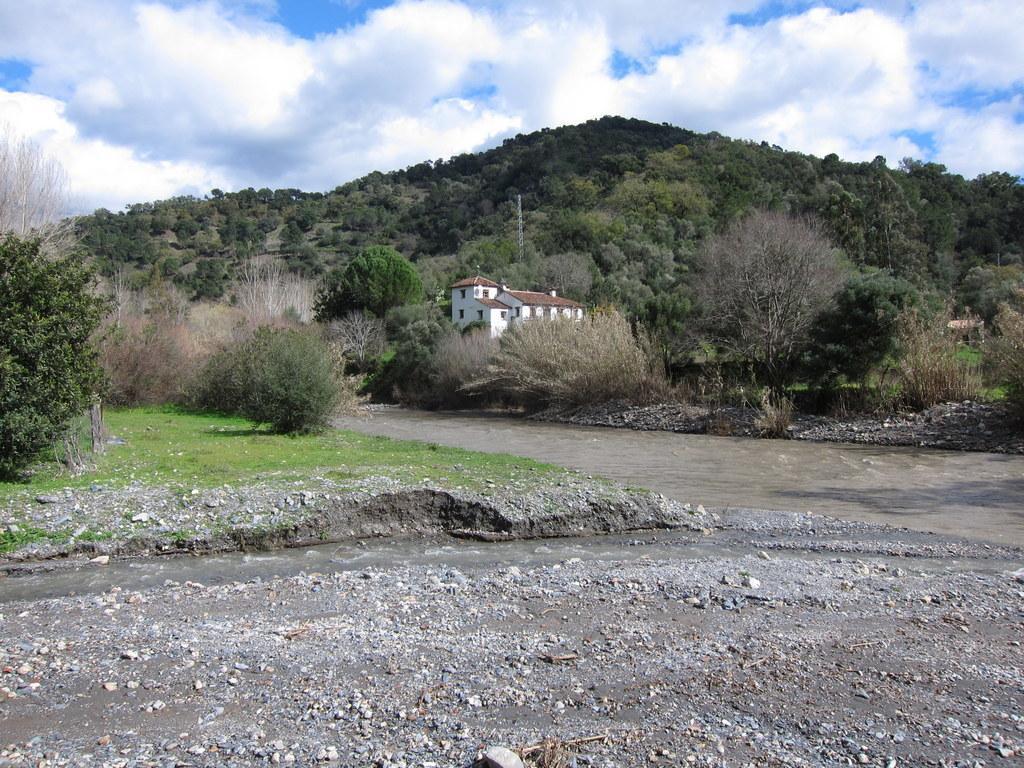In one or two sentences, can you explain what this image depicts? In this image there are clouds in the sky, there are mountains, there are trees on the mountains, there is a house, there is a pole on the mountains, there is a river, there are trees truncated towards the left of the image, there is grass, there are stones. 